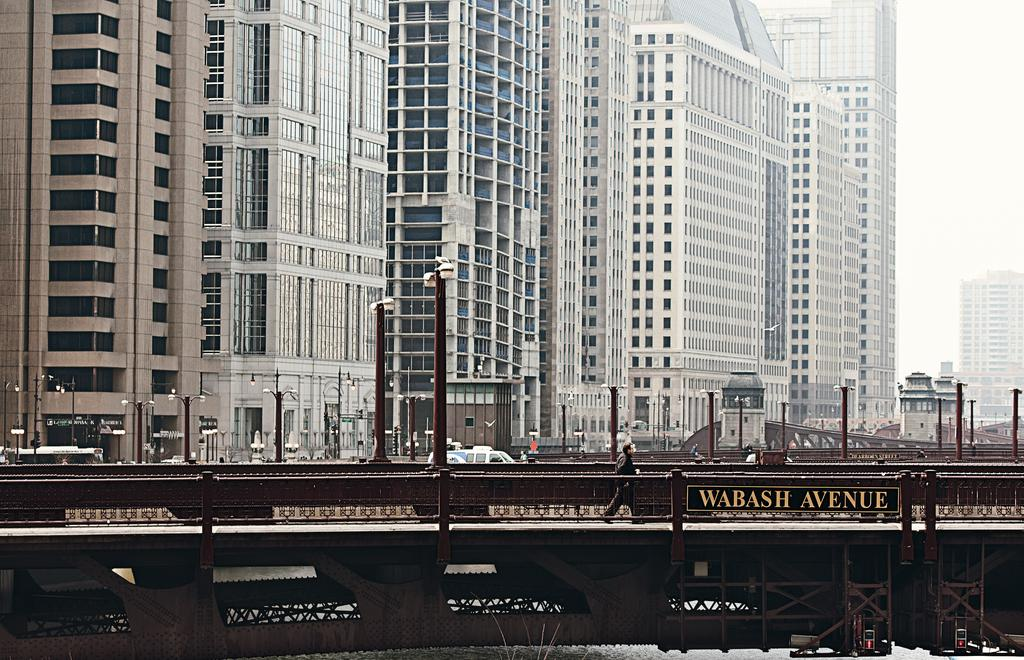What is the person in the image doing? A person is walking in the image. What can be seen in the image besides the person? There is fencing and poles in the image. What is visible in the background of the image? There are vehicles and buildings in the background of the image. What type of knowledge can be gained from the building in the image? There is no building present in the image, so no knowledge can be gained from it. 